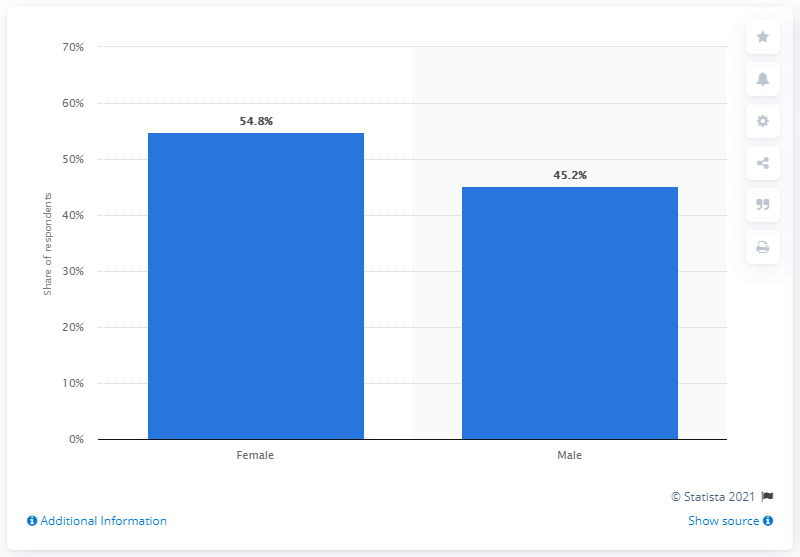List a handful of essential elements in this visual. According to a recent survey, 54.8% of female smartphone users in the United States have used mobile payment services in the past 12 months. 